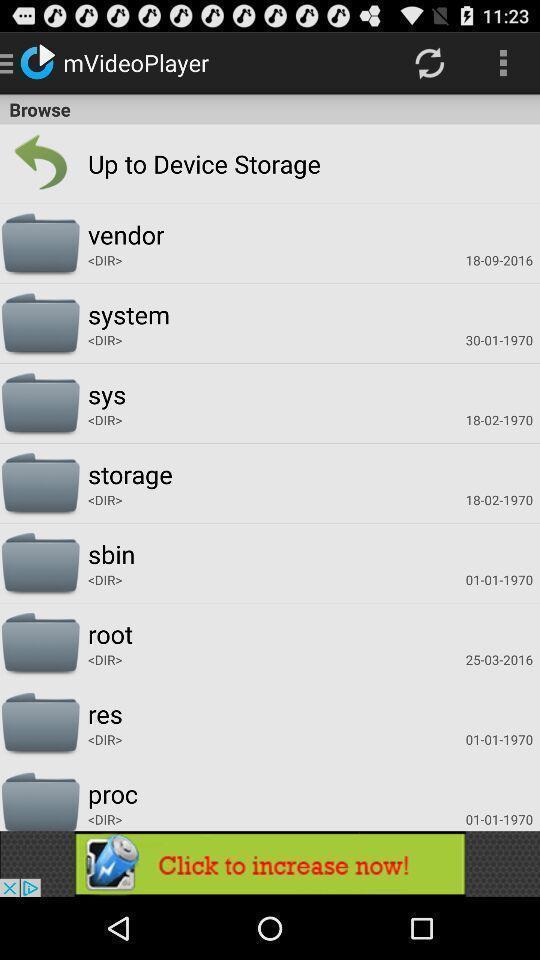Provide a textual representation of this image. Screen displaying multiple folders in a video player page. 